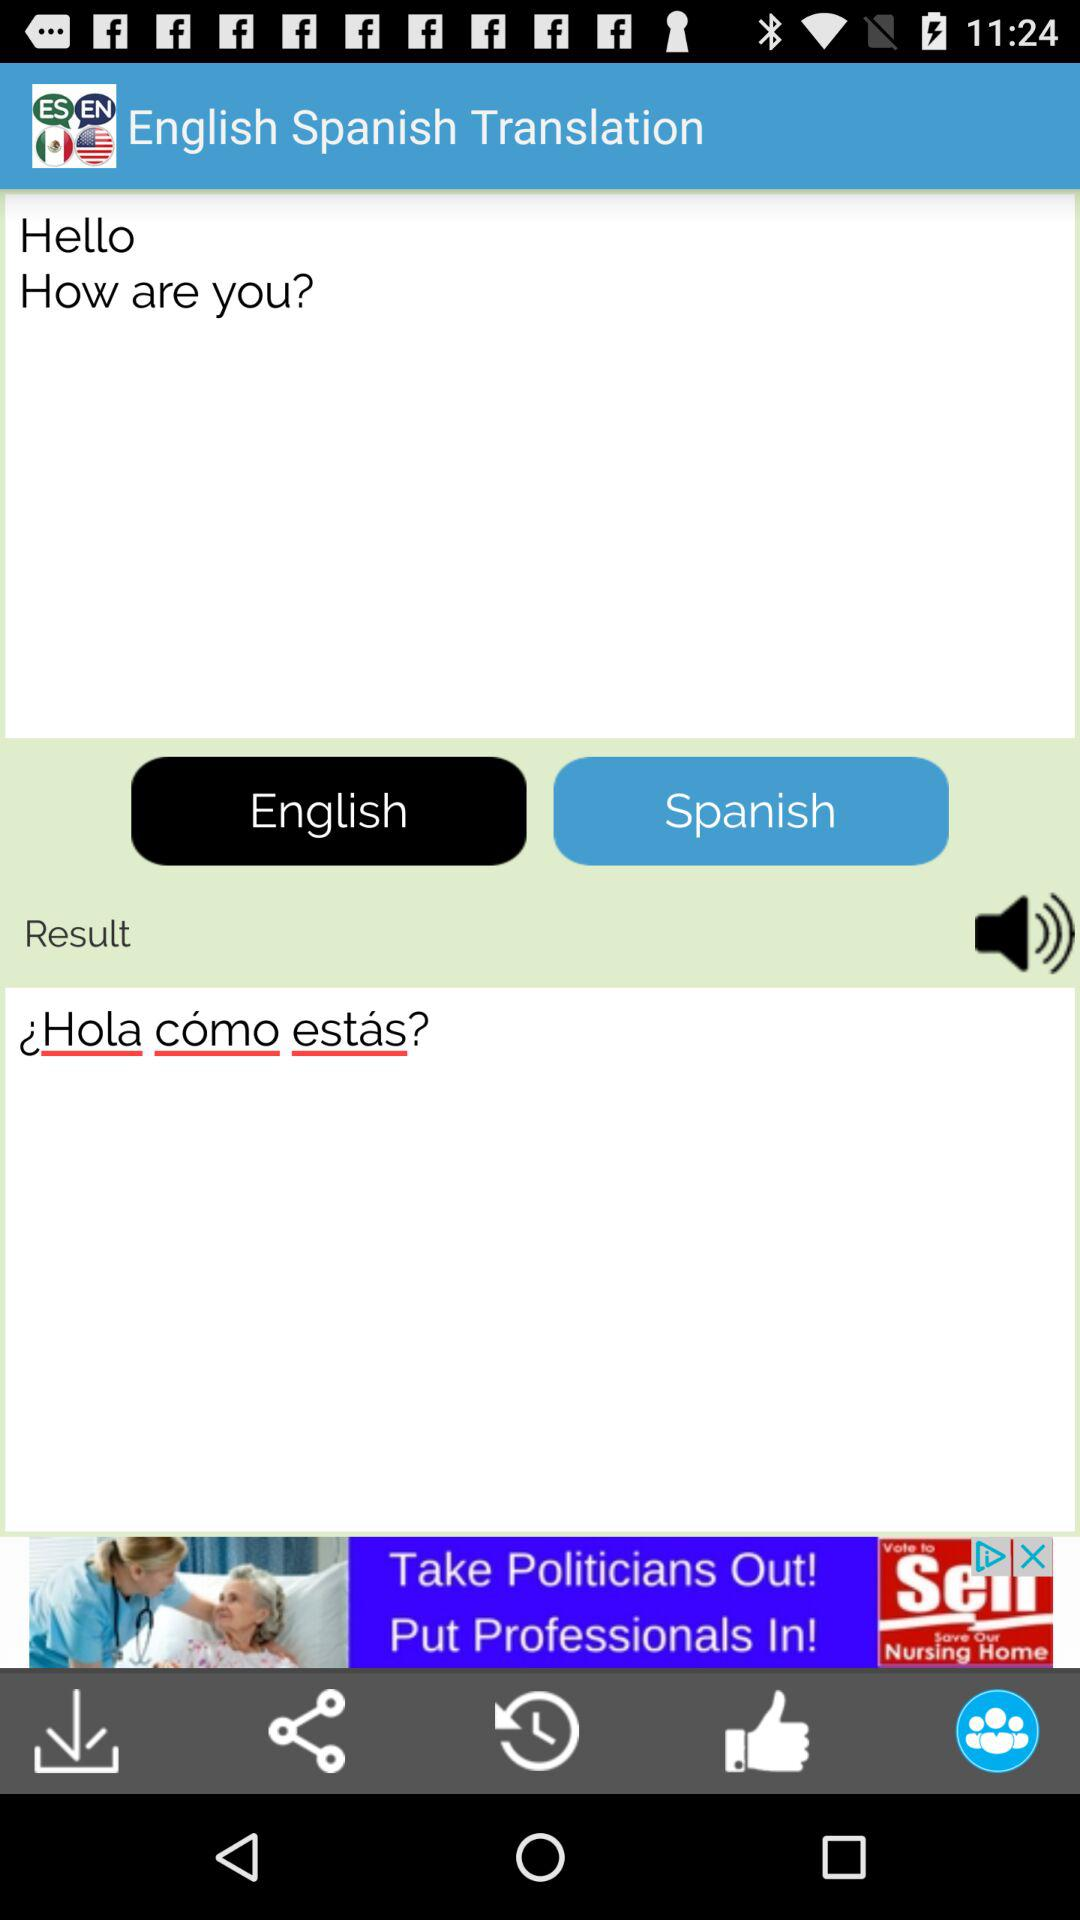How many languages are available in this app?
Answer the question using a single word or phrase. 2 